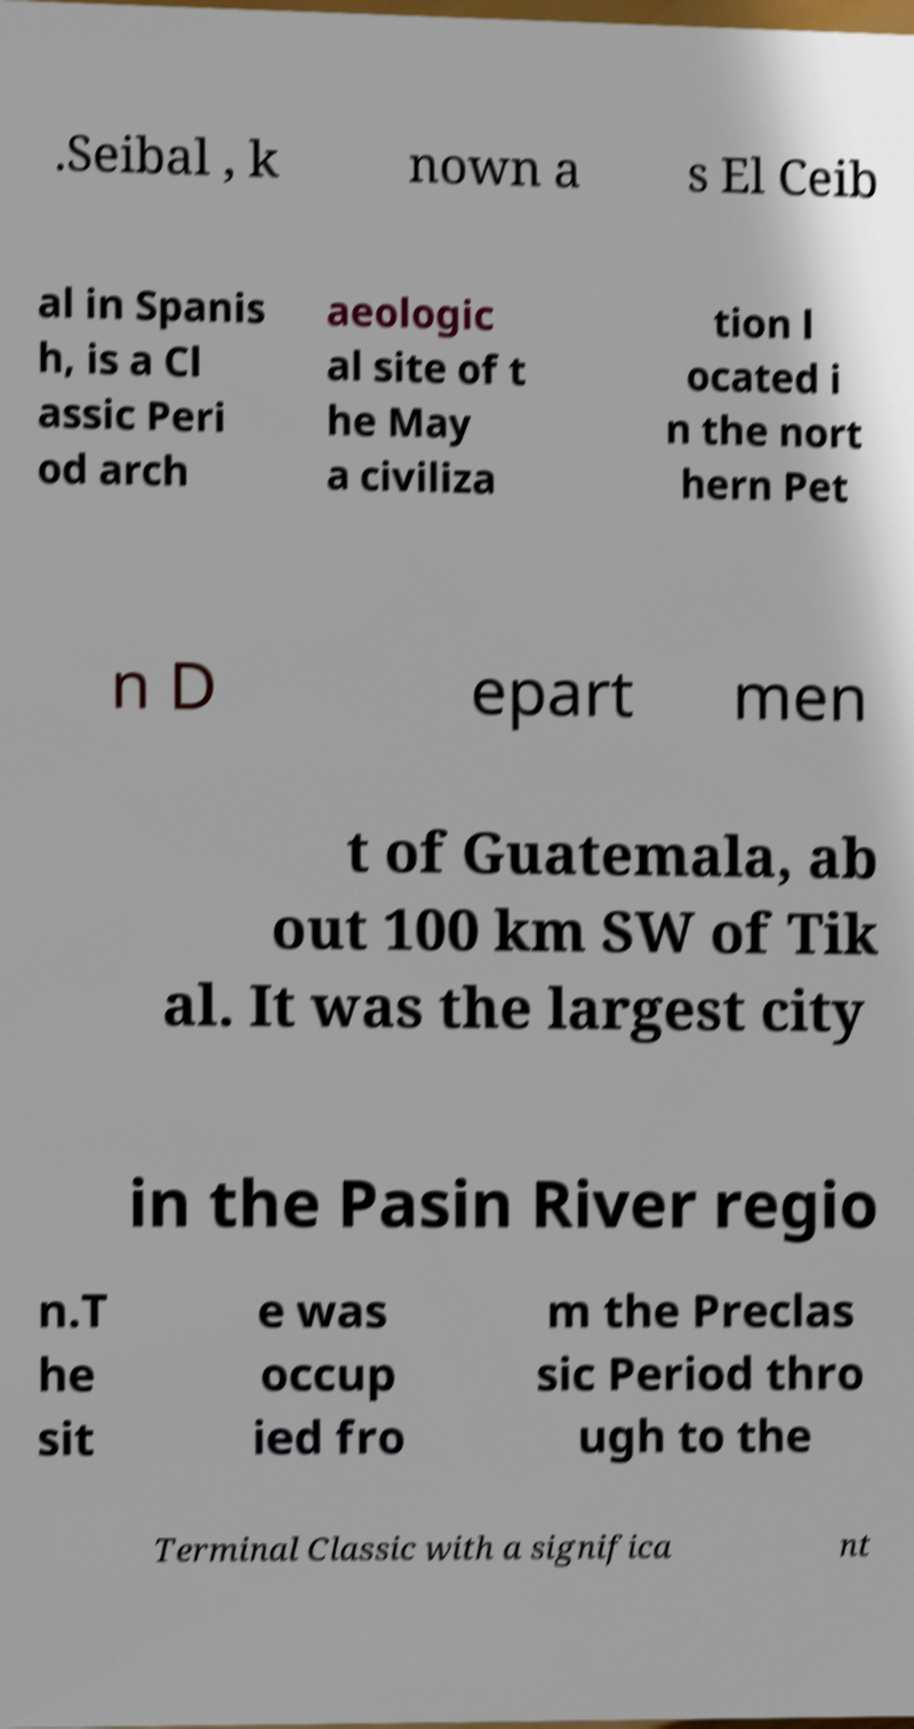There's text embedded in this image that I need extracted. Can you transcribe it verbatim? .Seibal , k nown a s El Ceib al in Spanis h, is a Cl assic Peri od arch aeologic al site of t he May a civiliza tion l ocated i n the nort hern Pet n D epart men t of Guatemala, ab out 100 km SW of Tik al. It was the largest city in the Pasin River regio n.T he sit e was occup ied fro m the Preclas sic Period thro ugh to the Terminal Classic with a significa nt 